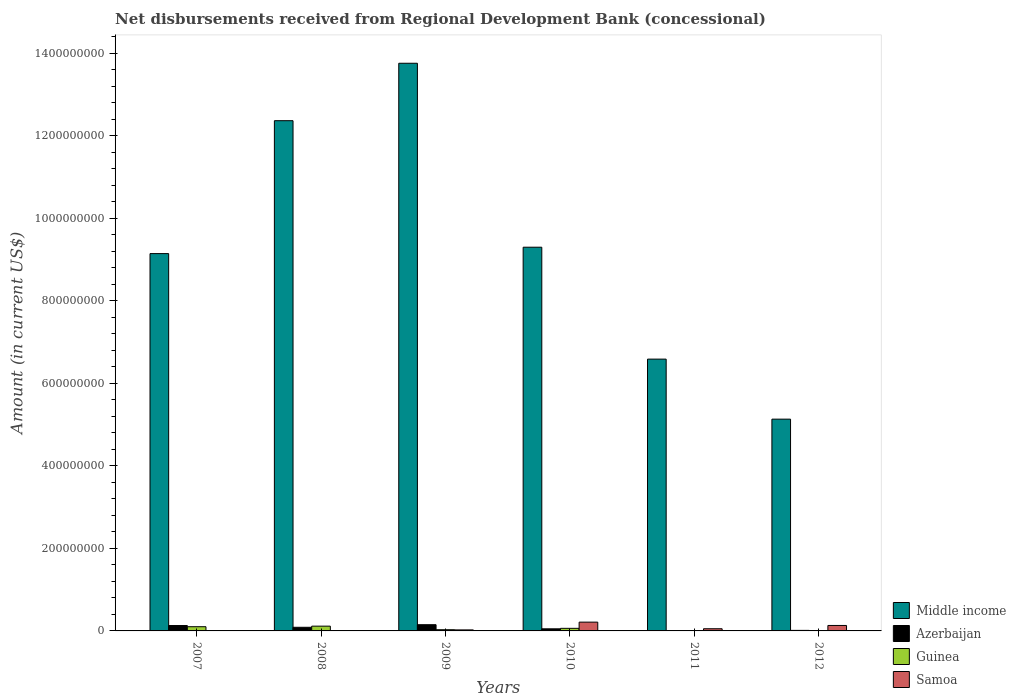How many groups of bars are there?
Ensure brevity in your answer.  6. Are the number of bars per tick equal to the number of legend labels?
Make the answer very short. No. How many bars are there on the 3rd tick from the left?
Your answer should be compact. 4. What is the amount of disbursements received from Regional Development Bank in Guinea in 2007?
Give a very brief answer. 1.02e+07. Across all years, what is the maximum amount of disbursements received from Regional Development Bank in Middle income?
Provide a short and direct response. 1.38e+09. Across all years, what is the minimum amount of disbursements received from Regional Development Bank in Middle income?
Your answer should be compact. 5.13e+08. In which year was the amount of disbursements received from Regional Development Bank in Samoa maximum?
Provide a succinct answer. 2010. What is the total amount of disbursements received from Regional Development Bank in Samoa in the graph?
Provide a short and direct response. 4.23e+07. What is the difference between the amount of disbursements received from Regional Development Bank in Azerbaijan in 2009 and that in 2012?
Your response must be concise. 1.38e+07. What is the difference between the amount of disbursements received from Regional Development Bank in Samoa in 2011 and the amount of disbursements received from Regional Development Bank in Middle income in 2012?
Provide a succinct answer. -5.08e+08. What is the average amount of disbursements received from Regional Development Bank in Middle income per year?
Give a very brief answer. 9.38e+08. In the year 2009, what is the difference between the amount of disbursements received from Regional Development Bank in Guinea and amount of disbursements received from Regional Development Bank in Azerbaijan?
Provide a succinct answer. -1.21e+07. What is the ratio of the amount of disbursements received from Regional Development Bank in Samoa in 2010 to that in 2012?
Give a very brief answer. 1.61. What is the difference between the highest and the second highest amount of disbursements received from Regional Development Bank in Guinea?
Offer a very short reply. 1.36e+06. What is the difference between the highest and the lowest amount of disbursements received from Regional Development Bank in Guinea?
Offer a terse response. 1.16e+07. Is it the case that in every year, the sum of the amount of disbursements received from Regional Development Bank in Middle income and amount of disbursements received from Regional Development Bank in Guinea is greater than the sum of amount of disbursements received from Regional Development Bank in Azerbaijan and amount of disbursements received from Regional Development Bank in Samoa?
Ensure brevity in your answer.  Yes. What is the difference between two consecutive major ticks on the Y-axis?
Your response must be concise. 2.00e+08. Are the values on the major ticks of Y-axis written in scientific E-notation?
Provide a succinct answer. No. Does the graph contain grids?
Your answer should be compact. No. Where does the legend appear in the graph?
Your answer should be very brief. Bottom right. What is the title of the graph?
Offer a terse response. Net disbursements received from Regional Development Bank (concessional). Does "Jordan" appear as one of the legend labels in the graph?
Offer a very short reply. No. What is the Amount (in current US$) in Middle income in 2007?
Make the answer very short. 9.14e+08. What is the Amount (in current US$) in Azerbaijan in 2007?
Provide a short and direct response. 1.31e+07. What is the Amount (in current US$) in Guinea in 2007?
Offer a terse response. 1.02e+07. What is the Amount (in current US$) of Middle income in 2008?
Offer a very short reply. 1.24e+09. What is the Amount (in current US$) in Azerbaijan in 2008?
Your answer should be very brief. 8.81e+06. What is the Amount (in current US$) in Guinea in 2008?
Offer a very short reply. 1.16e+07. What is the Amount (in current US$) of Middle income in 2009?
Your answer should be compact. 1.38e+09. What is the Amount (in current US$) of Azerbaijan in 2009?
Keep it short and to the point. 1.51e+07. What is the Amount (in current US$) of Guinea in 2009?
Your answer should be very brief. 2.93e+06. What is the Amount (in current US$) of Samoa in 2009?
Provide a succinct answer. 2.48e+06. What is the Amount (in current US$) of Middle income in 2010?
Provide a succinct answer. 9.30e+08. What is the Amount (in current US$) in Azerbaijan in 2010?
Give a very brief answer. 5.08e+06. What is the Amount (in current US$) in Guinea in 2010?
Provide a short and direct response. 6.26e+06. What is the Amount (in current US$) of Samoa in 2010?
Give a very brief answer. 2.13e+07. What is the Amount (in current US$) of Middle income in 2011?
Your response must be concise. 6.58e+08. What is the Amount (in current US$) in Azerbaijan in 2011?
Your answer should be very brief. 0. What is the Amount (in current US$) of Guinea in 2011?
Provide a succinct answer. 0. What is the Amount (in current US$) in Samoa in 2011?
Make the answer very short. 5.29e+06. What is the Amount (in current US$) of Middle income in 2012?
Provide a succinct answer. 5.13e+08. What is the Amount (in current US$) of Azerbaijan in 2012?
Your response must be concise. 1.30e+06. What is the Amount (in current US$) in Guinea in 2012?
Keep it short and to the point. 0. What is the Amount (in current US$) of Samoa in 2012?
Provide a short and direct response. 1.32e+07. Across all years, what is the maximum Amount (in current US$) of Middle income?
Offer a terse response. 1.38e+09. Across all years, what is the maximum Amount (in current US$) in Azerbaijan?
Offer a very short reply. 1.51e+07. Across all years, what is the maximum Amount (in current US$) of Guinea?
Your answer should be compact. 1.16e+07. Across all years, what is the maximum Amount (in current US$) in Samoa?
Make the answer very short. 2.13e+07. Across all years, what is the minimum Amount (in current US$) of Middle income?
Provide a short and direct response. 5.13e+08. Across all years, what is the minimum Amount (in current US$) of Guinea?
Offer a very short reply. 0. What is the total Amount (in current US$) of Middle income in the graph?
Provide a short and direct response. 5.63e+09. What is the total Amount (in current US$) of Azerbaijan in the graph?
Provide a short and direct response. 4.33e+07. What is the total Amount (in current US$) of Guinea in the graph?
Your response must be concise. 3.10e+07. What is the total Amount (in current US$) in Samoa in the graph?
Keep it short and to the point. 4.23e+07. What is the difference between the Amount (in current US$) in Middle income in 2007 and that in 2008?
Your answer should be very brief. -3.22e+08. What is the difference between the Amount (in current US$) in Azerbaijan in 2007 and that in 2008?
Keep it short and to the point. 4.26e+06. What is the difference between the Amount (in current US$) in Guinea in 2007 and that in 2008?
Ensure brevity in your answer.  -1.36e+06. What is the difference between the Amount (in current US$) of Middle income in 2007 and that in 2009?
Your response must be concise. -4.61e+08. What is the difference between the Amount (in current US$) in Azerbaijan in 2007 and that in 2009?
Offer a terse response. -2.00e+06. What is the difference between the Amount (in current US$) in Guinea in 2007 and that in 2009?
Offer a very short reply. 7.29e+06. What is the difference between the Amount (in current US$) in Middle income in 2007 and that in 2010?
Your answer should be compact. -1.55e+07. What is the difference between the Amount (in current US$) of Azerbaijan in 2007 and that in 2010?
Your response must be concise. 7.98e+06. What is the difference between the Amount (in current US$) in Guinea in 2007 and that in 2010?
Your response must be concise. 3.96e+06. What is the difference between the Amount (in current US$) in Middle income in 2007 and that in 2011?
Provide a short and direct response. 2.56e+08. What is the difference between the Amount (in current US$) in Middle income in 2007 and that in 2012?
Your answer should be compact. 4.01e+08. What is the difference between the Amount (in current US$) of Azerbaijan in 2007 and that in 2012?
Keep it short and to the point. 1.18e+07. What is the difference between the Amount (in current US$) in Middle income in 2008 and that in 2009?
Your answer should be very brief. -1.39e+08. What is the difference between the Amount (in current US$) of Azerbaijan in 2008 and that in 2009?
Provide a short and direct response. -6.26e+06. What is the difference between the Amount (in current US$) in Guinea in 2008 and that in 2009?
Offer a very short reply. 8.64e+06. What is the difference between the Amount (in current US$) in Middle income in 2008 and that in 2010?
Give a very brief answer. 3.07e+08. What is the difference between the Amount (in current US$) of Azerbaijan in 2008 and that in 2010?
Offer a very short reply. 3.73e+06. What is the difference between the Amount (in current US$) of Guinea in 2008 and that in 2010?
Your answer should be very brief. 5.31e+06. What is the difference between the Amount (in current US$) of Middle income in 2008 and that in 2011?
Ensure brevity in your answer.  5.78e+08. What is the difference between the Amount (in current US$) in Middle income in 2008 and that in 2012?
Your answer should be very brief. 7.23e+08. What is the difference between the Amount (in current US$) of Azerbaijan in 2008 and that in 2012?
Give a very brief answer. 7.52e+06. What is the difference between the Amount (in current US$) of Middle income in 2009 and that in 2010?
Your answer should be compact. 4.46e+08. What is the difference between the Amount (in current US$) in Azerbaijan in 2009 and that in 2010?
Your answer should be very brief. 9.99e+06. What is the difference between the Amount (in current US$) in Guinea in 2009 and that in 2010?
Ensure brevity in your answer.  -3.33e+06. What is the difference between the Amount (in current US$) of Samoa in 2009 and that in 2010?
Provide a short and direct response. -1.88e+07. What is the difference between the Amount (in current US$) of Middle income in 2009 and that in 2011?
Offer a very short reply. 7.17e+08. What is the difference between the Amount (in current US$) in Samoa in 2009 and that in 2011?
Your answer should be compact. -2.80e+06. What is the difference between the Amount (in current US$) in Middle income in 2009 and that in 2012?
Offer a terse response. 8.62e+08. What is the difference between the Amount (in current US$) of Azerbaijan in 2009 and that in 2012?
Offer a terse response. 1.38e+07. What is the difference between the Amount (in current US$) of Samoa in 2009 and that in 2012?
Provide a short and direct response. -1.07e+07. What is the difference between the Amount (in current US$) of Middle income in 2010 and that in 2011?
Give a very brief answer. 2.71e+08. What is the difference between the Amount (in current US$) in Samoa in 2010 and that in 2011?
Provide a short and direct response. 1.60e+07. What is the difference between the Amount (in current US$) in Middle income in 2010 and that in 2012?
Your response must be concise. 4.17e+08. What is the difference between the Amount (in current US$) in Azerbaijan in 2010 and that in 2012?
Provide a succinct answer. 3.79e+06. What is the difference between the Amount (in current US$) in Samoa in 2010 and that in 2012?
Give a very brief answer. 8.06e+06. What is the difference between the Amount (in current US$) in Middle income in 2011 and that in 2012?
Your answer should be very brief. 1.45e+08. What is the difference between the Amount (in current US$) in Samoa in 2011 and that in 2012?
Your answer should be compact. -7.94e+06. What is the difference between the Amount (in current US$) in Middle income in 2007 and the Amount (in current US$) in Azerbaijan in 2008?
Your response must be concise. 9.05e+08. What is the difference between the Amount (in current US$) of Middle income in 2007 and the Amount (in current US$) of Guinea in 2008?
Offer a very short reply. 9.03e+08. What is the difference between the Amount (in current US$) of Azerbaijan in 2007 and the Amount (in current US$) of Guinea in 2008?
Ensure brevity in your answer.  1.50e+06. What is the difference between the Amount (in current US$) of Middle income in 2007 and the Amount (in current US$) of Azerbaijan in 2009?
Ensure brevity in your answer.  8.99e+08. What is the difference between the Amount (in current US$) in Middle income in 2007 and the Amount (in current US$) in Guinea in 2009?
Keep it short and to the point. 9.11e+08. What is the difference between the Amount (in current US$) of Middle income in 2007 and the Amount (in current US$) of Samoa in 2009?
Your response must be concise. 9.12e+08. What is the difference between the Amount (in current US$) in Azerbaijan in 2007 and the Amount (in current US$) in Guinea in 2009?
Your answer should be compact. 1.01e+07. What is the difference between the Amount (in current US$) in Azerbaijan in 2007 and the Amount (in current US$) in Samoa in 2009?
Your response must be concise. 1.06e+07. What is the difference between the Amount (in current US$) in Guinea in 2007 and the Amount (in current US$) in Samoa in 2009?
Make the answer very short. 7.73e+06. What is the difference between the Amount (in current US$) in Middle income in 2007 and the Amount (in current US$) in Azerbaijan in 2010?
Ensure brevity in your answer.  9.09e+08. What is the difference between the Amount (in current US$) in Middle income in 2007 and the Amount (in current US$) in Guinea in 2010?
Your answer should be compact. 9.08e+08. What is the difference between the Amount (in current US$) in Middle income in 2007 and the Amount (in current US$) in Samoa in 2010?
Keep it short and to the point. 8.93e+08. What is the difference between the Amount (in current US$) of Azerbaijan in 2007 and the Amount (in current US$) of Guinea in 2010?
Provide a succinct answer. 6.81e+06. What is the difference between the Amount (in current US$) of Azerbaijan in 2007 and the Amount (in current US$) of Samoa in 2010?
Your answer should be compact. -8.22e+06. What is the difference between the Amount (in current US$) of Guinea in 2007 and the Amount (in current US$) of Samoa in 2010?
Provide a short and direct response. -1.11e+07. What is the difference between the Amount (in current US$) in Middle income in 2007 and the Amount (in current US$) in Samoa in 2011?
Provide a short and direct response. 9.09e+08. What is the difference between the Amount (in current US$) of Azerbaijan in 2007 and the Amount (in current US$) of Samoa in 2011?
Offer a very short reply. 7.78e+06. What is the difference between the Amount (in current US$) of Guinea in 2007 and the Amount (in current US$) of Samoa in 2011?
Offer a terse response. 4.92e+06. What is the difference between the Amount (in current US$) in Middle income in 2007 and the Amount (in current US$) in Azerbaijan in 2012?
Offer a very short reply. 9.13e+08. What is the difference between the Amount (in current US$) in Middle income in 2007 and the Amount (in current US$) in Samoa in 2012?
Ensure brevity in your answer.  9.01e+08. What is the difference between the Amount (in current US$) of Azerbaijan in 2007 and the Amount (in current US$) of Samoa in 2012?
Make the answer very short. -1.63e+05. What is the difference between the Amount (in current US$) of Guinea in 2007 and the Amount (in current US$) of Samoa in 2012?
Ensure brevity in your answer.  -3.02e+06. What is the difference between the Amount (in current US$) of Middle income in 2008 and the Amount (in current US$) of Azerbaijan in 2009?
Your response must be concise. 1.22e+09. What is the difference between the Amount (in current US$) of Middle income in 2008 and the Amount (in current US$) of Guinea in 2009?
Your answer should be compact. 1.23e+09. What is the difference between the Amount (in current US$) of Middle income in 2008 and the Amount (in current US$) of Samoa in 2009?
Ensure brevity in your answer.  1.23e+09. What is the difference between the Amount (in current US$) of Azerbaijan in 2008 and the Amount (in current US$) of Guinea in 2009?
Your response must be concise. 5.89e+06. What is the difference between the Amount (in current US$) in Azerbaijan in 2008 and the Amount (in current US$) in Samoa in 2009?
Your answer should be compact. 6.33e+06. What is the difference between the Amount (in current US$) in Guinea in 2008 and the Amount (in current US$) in Samoa in 2009?
Provide a short and direct response. 9.09e+06. What is the difference between the Amount (in current US$) in Middle income in 2008 and the Amount (in current US$) in Azerbaijan in 2010?
Provide a succinct answer. 1.23e+09. What is the difference between the Amount (in current US$) in Middle income in 2008 and the Amount (in current US$) in Guinea in 2010?
Make the answer very short. 1.23e+09. What is the difference between the Amount (in current US$) of Middle income in 2008 and the Amount (in current US$) of Samoa in 2010?
Your answer should be very brief. 1.21e+09. What is the difference between the Amount (in current US$) of Azerbaijan in 2008 and the Amount (in current US$) of Guinea in 2010?
Your answer should be very brief. 2.56e+06. What is the difference between the Amount (in current US$) in Azerbaijan in 2008 and the Amount (in current US$) in Samoa in 2010?
Your answer should be very brief. -1.25e+07. What is the difference between the Amount (in current US$) of Guinea in 2008 and the Amount (in current US$) of Samoa in 2010?
Offer a very short reply. -9.72e+06. What is the difference between the Amount (in current US$) in Middle income in 2008 and the Amount (in current US$) in Samoa in 2011?
Offer a terse response. 1.23e+09. What is the difference between the Amount (in current US$) of Azerbaijan in 2008 and the Amount (in current US$) of Samoa in 2011?
Offer a terse response. 3.52e+06. What is the difference between the Amount (in current US$) in Guinea in 2008 and the Amount (in current US$) in Samoa in 2011?
Your answer should be very brief. 6.28e+06. What is the difference between the Amount (in current US$) of Middle income in 2008 and the Amount (in current US$) of Azerbaijan in 2012?
Ensure brevity in your answer.  1.23e+09. What is the difference between the Amount (in current US$) of Middle income in 2008 and the Amount (in current US$) of Samoa in 2012?
Your response must be concise. 1.22e+09. What is the difference between the Amount (in current US$) in Azerbaijan in 2008 and the Amount (in current US$) in Samoa in 2012?
Offer a very short reply. -4.42e+06. What is the difference between the Amount (in current US$) in Guinea in 2008 and the Amount (in current US$) in Samoa in 2012?
Provide a short and direct response. -1.66e+06. What is the difference between the Amount (in current US$) in Middle income in 2009 and the Amount (in current US$) in Azerbaijan in 2010?
Your answer should be compact. 1.37e+09. What is the difference between the Amount (in current US$) in Middle income in 2009 and the Amount (in current US$) in Guinea in 2010?
Offer a terse response. 1.37e+09. What is the difference between the Amount (in current US$) of Middle income in 2009 and the Amount (in current US$) of Samoa in 2010?
Provide a short and direct response. 1.35e+09. What is the difference between the Amount (in current US$) in Azerbaijan in 2009 and the Amount (in current US$) in Guinea in 2010?
Make the answer very short. 8.82e+06. What is the difference between the Amount (in current US$) in Azerbaijan in 2009 and the Amount (in current US$) in Samoa in 2010?
Provide a succinct answer. -6.22e+06. What is the difference between the Amount (in current US$) in Guinea in 2009 and the Amount (in current US$) in Samoa in 2010?
Ensure brevity in your answer.  -1.84e+07. What is the difference between the Amount (in current US$) in Middle income in 2009 and the Amount (in current US$) in Samoa in 2011?
Your response must be concise. 1.37e+09. What is the difference between the Amount (in current US$) of Azerbaijan in 2009 and the Amount (in current US$) of Samoa in 2011?
Provide a succinct answer. 9.78e+06. What is the difference between the Amount (in current US$) in Guinea in 2009 and the Amount (in current US$) in Samoa in 2011?
Make the answer very short. -2.36e+06. What is the difference between the Amount (in current US$) of Middle income in 2009 and the Amount (in current US$) of Azerbaijan in 2012?
Your response must be concise. 1.37e+09. What is the difference between the Amount (in current US$) of Middle income in 2009 and the Amount (in current US$) of Samoa in 2012?
Ensure brevity in your answer.  1.36e+09. What is the difference between the Amount (in current US$) in Azerbaijan in 2009 and the Amount (in current US$) in Samoa in 2012?
Your response must be concise. 1.84e+06. What is the difference between the Amount (in current US$) of Guinea in 2009 and the Amount (in current US$) of Samoa in 2012?
Offer a terse response. -1.03e+07. What is the difference between the Amount (in current US$) of Middle income in 2010 and the Amount (in current US$) of Samoa in 2011?
Your answer should be very brief. 9.24e+08. What is the difference between the Amount (in current US$) of Azerbaijan in 2010 and the Amount (in current US$) of Samoa in 2011?
Give a very brief answer. -2.05e+05. What is the difference between the Amount (in current US$) of Guinea in 2010 and the Amount (in current US$) of Samoa in 2011?
Your answer should be compact. 9.69e+05. What is the difference between the Amount (in current US$) in Middle income in 2010 and the Amount (in current US$) in Azerbaijan in 2012?
Your response must be concise. 9.28e+08. What is the difference between the Amount (in current US$) of Middle income in 2010 and the Amount (in current US$) of Samoa in 2012?
Your answer should be very brief. 9.16e+08. What is the difference between the Amount (in current US$) in Azerbaijan in 2010 and the Amount (in current US$) in Samoa in 2012?
Give a very brief answer. -8.15e+06. What is the difference between the Amount (in current US$) in Guinea in 2010 and the Amount (in current US$) in Samoa in 2012?
Offer a terse response. -6.97e+06. What is the difference between the Amount (in current US$) of Middle income in 2011 and the Amount (in current US$) of Azerbaijan in 2012?
Your response must be concise. 6.57e+08. What is the difference between the Amount (in current US$) in Middle income in 2011 and the Amount (in current US$) in Samoa in 2012?
Provide a succinct answer. 6.45e+08. What is the average Amount (in current US$) in Middle income per year?
Give a very brief answer. 9.38e+08. What is the average Amount (in current US$) of Azerbaijan per year?
Offer a very short reply. 7.22e+06. What is the average Amount (in current US$) of Guinea per year?
Offer a terse response. 5.16e+06. What is the average Amount (in current US$) of Samoa per year?
Offer a terse response. 7.05e+06. In the year 2007, what is the difference between the Amount (in current US$) in Middle income and Amount (in current US$) in Azerbaijan?
Provide a short and direct response. 9.01e+08. In the year 2007, what is the difference between the Amount (in current US$) in Middle income and Amount (in current US$) in Guinea?
Your answer should be very brief. 9.04e+08. In the year 2007, what is the difference between the Amount (in current US$) in Azerbaijan and Amount (in current US$) in Guinea?
Your response must be concise. 2.86e+06. In the year 2008, what is the difference between the Amount (in current US$) in Middle income and Amount (in current US$) in Azerbaijan?
Provide a succinct answer. 1.23e+09. In the year 2008, what is the difference between the Amount (in current US$) of Middle income and Amount (in current US$) of Guinea?
Keep it short and to the point. 1.22e+09. In the year 2008, what is the difference between the Amount (in current US$) of Azerbaijan and Amount (in current US$) of Guinea?
Your answer should be compact. -2.76e+06. In the year 2009, what is the difference between the Amount (in current US$) of Middle income and Amount (in current US$) of Azerbaijan?
Offer a very short reply. 1.36e+09. In the year 2009, what is the difference between the Amount (in current US$) of Middle income and Amount (in current US$) of Guinea?
Your answer should be very brief. 1.37e+09. In the year 2009, what is the difference between the Amount (in current US$) of Middle income and Amount (in current US$) of Samoa?
Your answer should be very brief. 1.37e+09. In the year 2009, what is the difference between the Amount (in current US$) in Azerbaijan and Amount (in current US$) in Guinea?
Your response must be concise. 1.21e+07. In the year 2009, what is the difference between the Amount (in current US$) in Azerbaijan and Amount (in current US$) in Samoa?
Give a very brief answer. 1.26e+07. In the year 2009, what is the difference between the Amount (in current US$) in Guinea and Amount (in current US$) in Samoa?
Offer a terse response. 4.41e+05. In the year 2010, what is the difference between the Amount (in current US$) in Middle income and Amount (in current US$) in Azerbaijan?
Offer a terse response. 9.24e+08. In the year 2010, what is the difference between the Amount (in current US$) in Middle income and Amount (in current US$) in Guinea?
Offer a terse response. 9.23e+08. In the year 2010, what is the difference between the Amount (in current US$) of Middle income and Amount (in current US$) of Samoa?
Offer a terse response. 9.08e+08. In the year 2010, what is the difference between the Amount (in current US$) of Azerbaijan and Amount (in current US$) of Guinea?
Give a very brief answer. -1.17e+06. In the year 2010, what is the difference between the Amount (in current US$) in Azerbaijan and Amount (in current US$) in Samoa?
Make the answer very short. -1.62e+07. In the year 2010, what is the difference between the Amount (in current US$) in Guinea and Amount (in current US$) in Samoa?
Offer a terse response. -1.50e+07. In the year 2011, what is the difference between the Amount (in current US$) of Middle income and Amount (in current US$) of Samoa?
Keep it short and to the point. 6.53e+08. In the year 2012, what is the difference between the Amount (in current US$) of Middle income and Amount (in current US$) of Azerbaijan?
Offer a terse response. 5.12e+08. In the year 2012, what is the difference between the Amount (in current US$) in Middle income and Amount (in current US$) in Samoa?
Make the answer very short. 5.00e+08. In the year 2012, what is the difference between the Amount (in current US$) in Azerbaijan and Amount (in current US$) in Samoa?
Your answer should be compact. -1.19e+07. What is the ratio of the Amount (in current US$) of Middle income in 2007 to that in 2008?
Offer a very short reply. 0.74. What is the ratio of the Amount (in current US$) of Azerbaijan in 2007 to that in 2008?
Give a very brief answer. 1.48. What is the ratio of the Amount (in current US$) in Guinea in 2007 to that in 2008?
Offer a terse response. 0.88. What is the ratio of the Amount (in current US$) in Middle income in 2007 to that in 2009?
Your response must be concise. 0.66. What is the ratio of the Amount (in current US$) of Azerbaijan in 2007 to that in 2009?
Your answer should be compact. 0.87. What is the ratio of the Amount (in current US$) in Guinea in 2007 to that in 2009?
Give a very brief answer. 3.49. What is the ratio of the Amount (in current US$) in Middle income in 2007 to that in 2010?
Provide a succinct answer. 0.98. What is the ratio of the Amount (in current US$) of Azerbaijan in 2007 to that in 2010?
Your answer should be compact. 2.57. What is the ratio of the Amount (in current US$) in Guinea in 2007 to that in 2010?
Your response must be concise. 1.63. What is the ratio of the Amount (in current US$) of Middle income in 2007 to that in 2011?
Your answer should be very brief. 1.39. What is the ratio of the Amount (in current US$) of Middle income in 2007 to that in 2012?
Ensure brevity in your answer.  1.78. What is the ratio of the Amount (in current US$) in Azerbaijan in 2007 to that in 2012?
Your response must be concise. 10.08. What is the ratio of the Amount (in current US$) of Middle income in 2008 to that in 2009?
Ensure brevity in your answer.  0.9. What is the ratio of the Amount (in current US$) in Azerbaijan in 2008 to that in 2009?
Offer a very short reply. 0.58. What is the ratio of the Amount (in current US$) of Guinea in 2008 to that in 2009?
Keep it short and to the point. 3.95. What is the ratio of the Amount (in current US$) in Middle income in 2008 to that in 2010?
Your answer should be very brief. 1.33. What is the ratio of the Amount (in current US$) of Azerbaijan in 2008 to that in 2010?
Make the answer very short. 1.73. What is the ratio of the Amount (in current US$) of Guinea in 2008 to that in 2010?
Offer a terse response. 1.85. What is the ratio of the Amount (in current US$) in Middle income in 2008 to that in 2011?
Give a very brief answer. 1.88. What is the ratio of the Amount (in current US$) in Middle income in 2008 to that in 2012?
Your answer should be very brief. 2.41. What is the ratio of the Amount (in current US$) of Azerbaijan in 2008 to that in 2012?
Provide a short and direct response. 6.8. What is the ratio of the Amount (in current US$) of Middle income in 2009 to that in 2010?
Ensure brevity in your answer.  1.48. What is the ratio of the Amount (in current US$) of Azerbaijan in 2009 to that in 2010?
Offer a terse response. 2.96. What is the ratio of the Amount (in current US$) of Guinea in 2009 to that in 2010?
Give a very brief answer. 0.47. What is the ratio of the Amount (in current US$) in Samoa in 2009 to that in 2010?
Keep it short and to the point. 0.12. What is the ratio of the Amount (in current US$) of Middle income in 2009 to that in 2011?
Your response must be concise. 2.09. What is the ratio of the Amount (in current US$) of Samoa in 2009 to that in 2011?
Provide a succinct answer. 0.47. What is the ratio of the Amount (in current US$) of Middle income in 2009 to that in 2012?
Keep it short and to the point. 2.68. What is the ratio of the Amount (in current US$) of Azerbaijan in 2009 to that in 2012?
Make the answer very short. 11.62. What is the ratio of the Amount (in current US$) in Samoa in 2009 to that in 2012?
Offer a very short reply. 0.19. What is the ratio of the Amount (in current US$) of Middle income in 2010 to that in 2011?
Make the answer very short. 1.41. What is the ratio of the Amount (in current US$) of Samoa in 2010 to that in 2011?
Keep it short and to the point. 4.03. What is the ratio of the Amount (in current US$) of Middle income in 2010 to that in 2012?
Provide a short and direct response. 1.81. What is the ratio of the Amount (in current US$) in Azerbaijan in 2010 to that in 2012?
Provide a succinct answer. 3.92. What is the ratio of the Amount (in current US$) of Samoa in 2010 to that in 2012?
Make the answer very short. 1.61. What is the ratio of the Amount (in current US$) of Middle income in 2011 to that in 2012?
Your response must be concise. 1.28. What is the ratio of the Amount (in current US$) in Samoa in 2011 to that in 2012?
Your answer should be compact. 0.4. What is the difference between the highest and the second highest Amount (in current US$) in Middle income?
Offer a terse response. 1.39e+08. What is the difference between the highest and the second highest Amount (in current US$) of Azerbaijan?
Offer a very short reply. 2.00e+06. What is the difference between the highest and the second highest Amount (in current US$) in Guinea?
Give a very brief answer. 1.36e+06. What is the difference between the highest and the second highest Amount (in current US$) of Samoa?
Keep it short and to the point. 8.06e+06. What is the difference between the highest and the lowest Amount (in current US$) of Middle income?
Offer a terse response. 8.62e+08. What is the difference between the highest and the lowest Amount (in current US$) in Azerbaijan?
Keep it short and to the point. 1.51e+07. What is the difference between the highest and the lowest Amount (in current US$) of Guinea?
Your answer should be compact. 1.16e+07. What is the difference between the highest and the lowest Amount (in current US$) in Samoa?
Offer a terse response. 2.13e+07. 